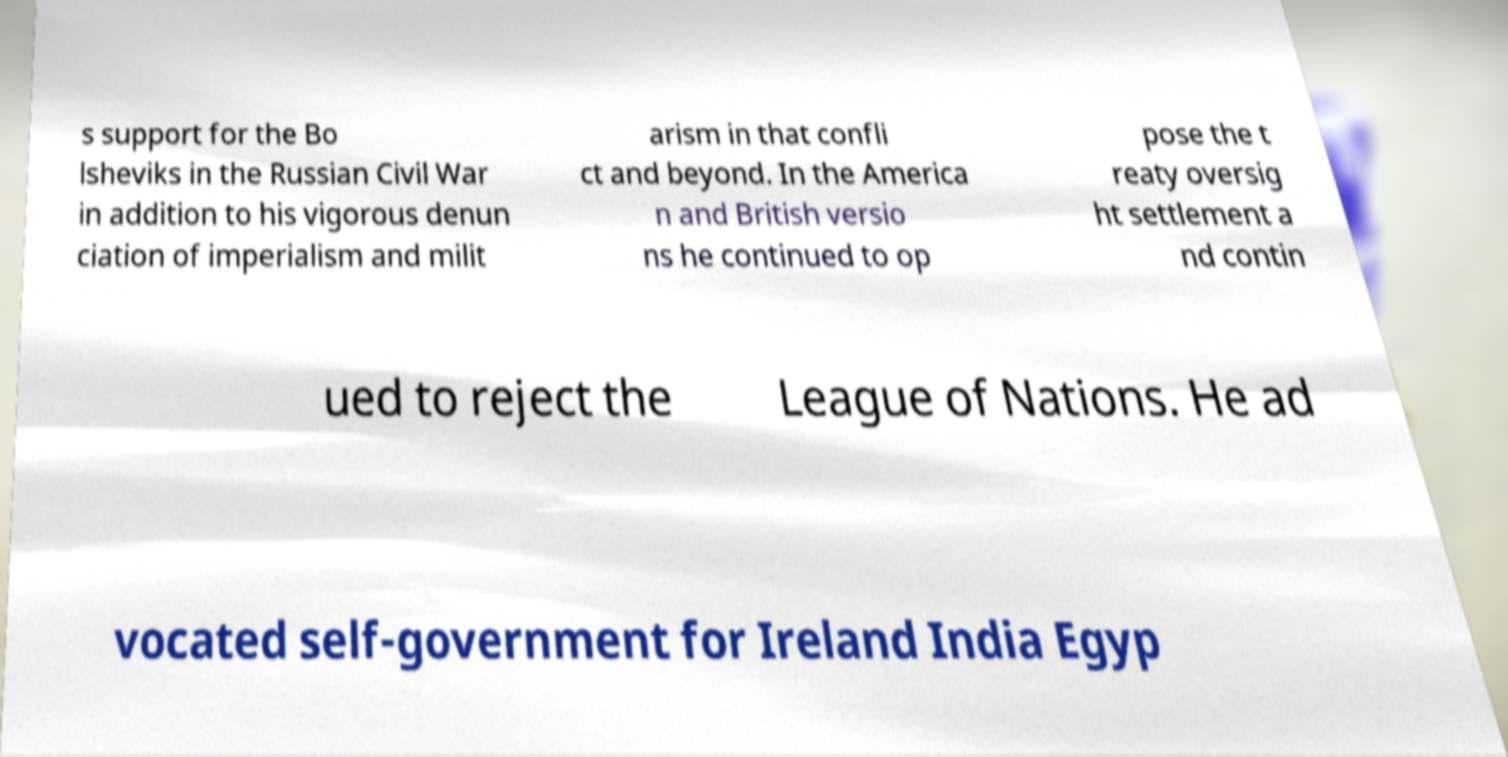Can you accurately transcribe the text from the provided image for me? s support for the Bo lsheviks in the Russian Civil War in addition to his vigorous denun ciation of imperialism and milit arism in that confli ct and beyond. In the America n and British versio ns he continued to op pose the t reaty oversig ht settlement a nd contin ued to reject the League of Nations. He ad vocated self-government for Ireland India Egyp 